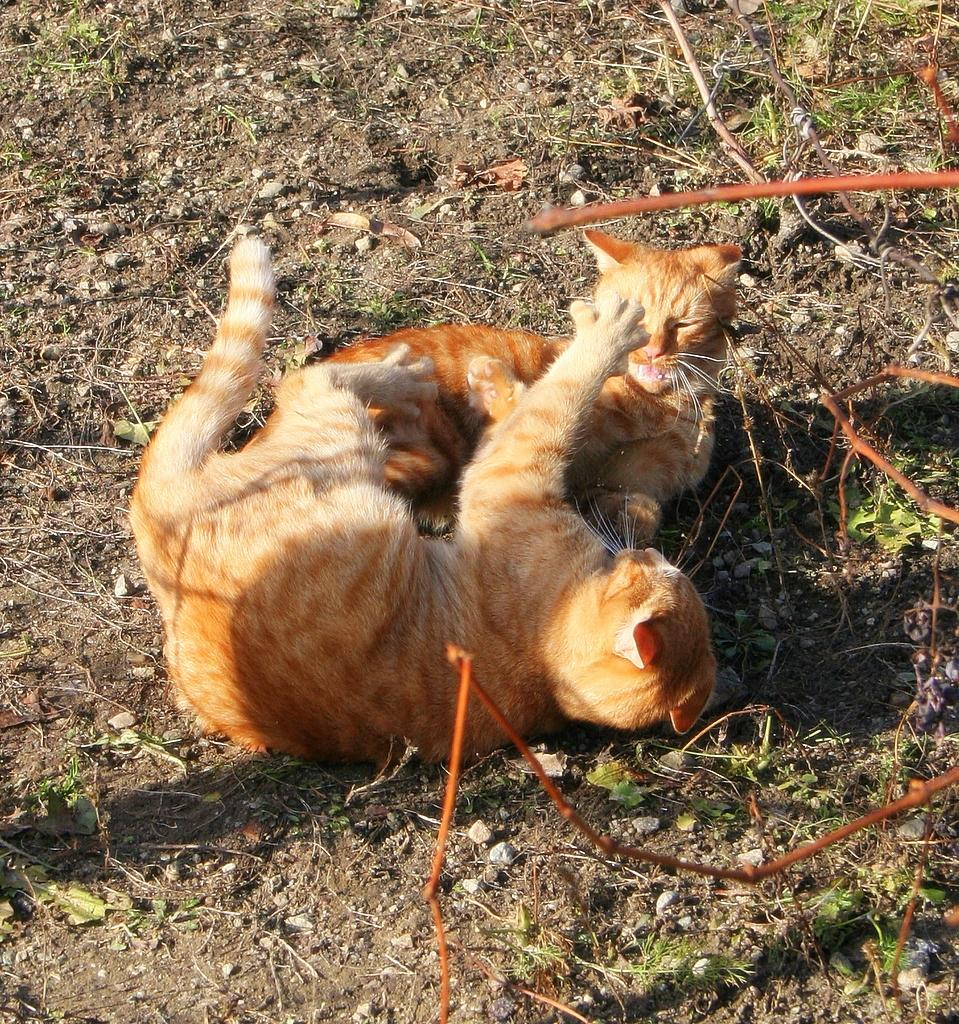How many cats are in the image? There are two cats in the image. What are the cats doing in the image? The cats are laying on the ground. What colors are the cats? The cats are in brown and cream color. What can be seen in the background of the image? There is grass in the background of the image. What color is the grass? The grass is green in color. What type of crowd can be seen gathering around the cats in the image? There is no crowd present in the image; it only features two cats laying on the ground. 